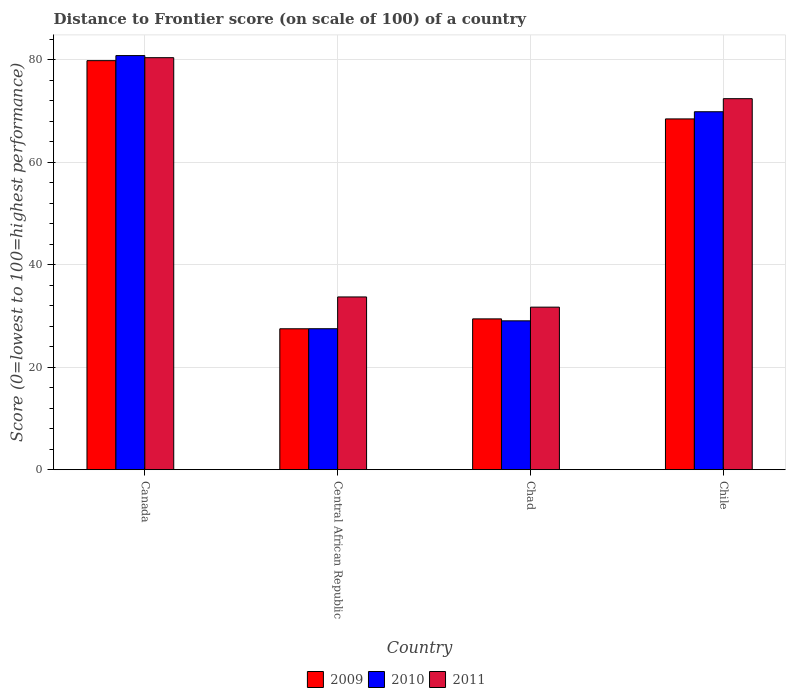How many different coloured bars are there?
Ensure brevity in your answer.  3. Are the number of bars on each tick of the X-axis equal?
Offer a very short reply. Yes. How many bars are there on the 4th tick from the left?
Provide a short and direct response. 3. How many bars are there on the 4th tick from the right?
Make the answer very short. 3. What is the label of the 4th group of bars from the left?
Keep it short and to the point. Chile. In how many cases, is the number of bars for a given country not equal to the number of legend labels?
Your answer should be compact. 0. What is the distance to frontier score of in 2009 in Chad?
Keep it short and to the point. 29.43. Across all countries, what is the maximum distance to frontier score of in 2009?
Your response must be concise. 79.82. Across all countries, what is the minimum distance to frontier score of in 2010?
Make the answer very short. 27.51. In which country was the distance to frontier score of in 2010 minimum?
Your response must be concise. Central African Republic. What is the total distance to frontier score of in 2011 in the graph?
Give a very brief answer. 218.23. What is the difference between the distance to frontier score of in 2010 in Central African Republic and that in Chile?
Provide a short and direct response. -42.34. What is the difference between the distance to frontier score of in 2009 in Canada and the distance to frontier score of in 2011 in Chad?
Provide a succinct answer. 48.1. What is the average distance to frontier score of in 2009 per country?
Your answer should be compact. 51.3. What is the difference between the distance to frontier score of of/in 2009 and distance to frontier score of of/in 2010 in Canada?
Make the answer very short. -0.99. In how many countries, is the distance to frontier score of in 2009 greater than 32?
Ensure brevity in your answer.  2. What is the ratio of the distance to frontier score of in 2010 in Chad to that in Chile?
Ensure brevity in your answer.  0.42. Is the distance to frontier score of in 2009 in Central African Republic less than that in Chad?
Ensure brevity in your answer.  Yes. What is the difference between the highest and the second highest distance to frontier score of in 2010?
Provide a short and direct response. 51.76. What is the difference between the highest and the lowest distance to frontier score of in 2010?
Offer a terse response. 53.3. In how many countries, is the distance to frontier score of in 2009 greater than the average distance to frontier score of in 2009 taken over all countries?
Offer a very short reply. 2. What does the 1st bar from the right in Chile represents?
Keep it short and to the point. 2011. Is it the case that in every country, the sum of the distance to frontier score of in 2011 and distance to frontier score of in 2009 is greater than the distance to frontier score of in 2010?
Offer a terse response. Yes. How many countries are there in the graph?
Provide a short and direct response. 4. Are the values on the major ticks of Y-axis written in scientific E-notation?
Your answer should be compact. No. Does the graph contain any zero values?
Your response must be concise. No. Where does the legend appear in the graph?
Keep it short and to the point. Bottom center. How many legend labels are there?
Keep it short and to the point. 3. What is the title of the graph?
Keep it short and to the point. Distance to Frontier score (on scale of 100) of a country. Does "1971" appear as one of the legend labels in the graph?
Offer a very short reply. No. What is the label or title of the X-axis?
Provide a succinct answer. Country. What is the label or title of the Y-axis?
Give a very brief answer. Score (0=lowest to 100=highest performance). What is the Score (0=lowest to 100=highest performance) of 2009 in Canada?
Provide a succinct answer. 79.82. What is the Score (0=lowest to 100=highest performance) of 2010 in Canada?
Your answer should be very brief. 80.81. What is the Score (0=lowest to 100=highest performance) in 2011 in Canada?
Make the answer very short. 80.4. What is the Score (0=lowest to 100=highest performance) of 2010 in Central African Republic?
Your answer should be compact. 27.51. What is the Score (0=lowest to 100=highest performance) in 2011 in Central African Republic?
Provide a short and direct response. 33.71. What is the Score (0=lowest to 100=highest performance) in 2009 in Chad?
Ensure brevity in your answer.  29.43. What is the Score (0=lowest to 100=highest performance) of 2010 in Chad?
Provide a short and direct response. 29.05. What is the Score (0=lowest to 100=highest performance) of 2011 in Chad?
Ensure brevity in your answer.  31.72. What is the Score (0=lowest to 100=highest performance) of 2009 in Chile?
Your answer should be compact. 68.45. What is the Score (0=lowest to 100=highest performance) in 2010 in Chile?
Offer a very short reply. 69.85. What is the Score (0=lowest to 100=highest performance) of 2011 in Chile?
Offer a terse response. 72.4. Across all countries, what is the maximum Score (0=lowest to 100=highest performance) in 2009?
Provide a succinct answer. 79.82. Across all countries, what is the maximum Score (0=lowest to 100=highest performance) in 2010?
Provide a succinct answer. 80.81. Across all countries, what is the maximum Score (0=lowest to 100=highest performance) in 2011?
Offer a very short reply. 80.4. Across all countries, what is the minimum Score (0=lowest to 100=highest performance) in 2009?
Give a very brief answer. 27.5. Across all countries, what is the minimum Score (0=lowest to 100=highest performance) in 2010?
Offer a terse response. 27.51. Across all countries, what is the minimum Score (0=lowest to 100=highest performance) in 2011?
Ensure brevity in your answer.  31.72. What is the total Score (0=lowest to 100=highest performance) in 2009 in the graph?
Your answer should be very brief. 205.2. What is the total Score (0=lowest to 100=highest performance) in 2010 in the graph?
Provide a short and direct response. 207.22. What is the total Score (0=lowest to 100=highest performance) of 2011 in the graph?
Ensure brevity in your answer.  218.23. What is the difference between the Score (0=lowest to 100=highest performance) in 2009 in Canada and that in Central African Republic?
Provide a short and direct response. 52.32. What is the difference between the Score (0=lowest to 100=highest performance) of 2010 in Canada and that in Central African Republic?
Your response must be concise. 53.3. What is the difference between the Score (0=lowest to 100=highest performance) in 2011 in Canada and that in Central African Republic?
Your answer should be very brief. 46.69. What is the difference between the Score (0=lowest to 100=highest performance) of 2009 in Canada and that in Chad?
Offer a terse response. 50.39. What is the difference between the Score (0=lowest to 100=highest performance) in 2010 in Canada and that in Chad?
Your answer should be very brief. 51.76. What is the difference between the Score (0=lowest to 100=highest performance) of 2011 in Canada and that in Chad?
Ensure brevity in your answer.  48.68. What is the difference between the Score (0=lowest to 100=highest performance) in 2009 in Canada and that in Chile?
Keep it short and to the point. 11.37. What is the difference between the Score (0=lowest to 100=highest performance) in 2010 in Canada and that in Chile?
Your answer should be compact. 10.96. What is the difference between the Score (0=lowest to 100=highest performance) of 2009 in Central African Republic and that in Chad?
Provide a succinct answer. -1.93. What is the difference between the Score (0=lowest to 100=highest performance) of 2010 in Central African Republic and that in Chad?
Your answer should be very brief. -1.54. What is the difference between the Score (0=lowest to 100=highest performance) of 2011 in Central African Republic and that in Chad?
Your response must be concise. 1.99. What is the difference between the Score (0=lowest to 100=highest performance) in 2009 in Central African Republic and that in Chile?
Your answer should be very brief. -40.95. What is the difference between the Score (0=lowest to 100=highest performance) of 2010 in Central African Republic and that in Chile?
Offer a very short reply. -42.34. What is the difference between the Score (0=lowest to 100=highest performance) in 2011 in Central African Republic and that in Chile?
Provide a succinct answer. -38.69. What is the difference between the Score (0=lowest to 100=highest performance) in 2009 in Chad and that in Chile?
Your answer should be very brief. -39.02. What is the difference between the Score (0=lowest to 100=highest performance) of 2010 in Chad and that in Chile?
Your answer should be compact. -40.8. What is the difference between the Score (0=lowest to 100=highest performance) in 2011 in Chad and that in Chile?
Ensure brevity in your answer.  -40.68. What is the difference between the Score (0=lowest to 100=highest performance) in 2009 in Canada and the Score (0=lowest to 100=highest performance) in 2010 in Central African Republic?
Offer a very short reply. 52.31. What is the difference between the Score (0=lowest to 100=highest performance) of 2009 in Canada and the Score (0=lowest to 100=highest performance) of 2011 in Central African Republic?
Your answer should be very brief. 46.11. What is the difference between the Score (0=lowest to 100=highest performance) of 2010 in Canada and the Score (0=lowest to 100=highest performance) of 2011 in Central African Republic?
Offer a terse response. 47.1. What is the difference between the Score (0=lowest to 100=highest performance) of 2009 in Canada and the Score (0=lowest to 100=highest performance) of 2010 in Chad?
Provide a short and direct response. 50.77. What is the difference between the Score (0=lowest to 100=highest performance) of 2009 in Canada and the Score (0=lowest to 100=highest performance) of 2011 in Chad?
Your answer should be very brief. 48.1. What is the difference between the Score (0=lowest to 100=highest performance) of 2010 in Canada and the Score (0=lowest to 100=highest performance) of 2011 in Chad?
Make the answer very short. 49.09. What is the difference between the Score (0=lowest to 100=highest performance) of 2009 in Canada and the Score (0=lowest to 100=highest performance) of 2010 in Chile?
Your answer should be very brief. 9.97. What is the difference between the Score (0=lowest to 100=highest performance) of 2009 in Canada and the Score (0=lowest to 100=highest performance) of 2011 in Chile?
Offer a terse response. 7.42. What is the difference between the Score (0=lowest to 100=highest performance) of 2010 in Canada and the Score (0=lowest to 100=highest performance) of 2011 in Chile?
Give a very brief answer. 8.41. What is the difference between the Score (0=lowest to 100=highest performance) of 2009 in Central African Republic and the Score (0=lowest to 100=highest performance) of 2010 in Chad?
Offer a terse response. -1.55. What is the difference between the Score (0=lowest to 100=highest performance) of 2009 in Central African Republic and the Score (0=lowest to 100=highest performance) of 2011 in Chad?
Your response must be concise. -4.22. What is the difference between the Score (0=lowest to 100=highest performance) of 2010 in Central African Republic and the Score (0=lowest to 100=highest performance) of 2011 in Chad?
Keep it short and to the point. -4.21. What is the difference between the Score (0=lowest to 100=highest performance) of 2009 in Central African Republic and the Score (0=lowest to 100=highest performance) of 2010 in Chile?
Offer a terse response. -42.35. What is the difference between the Score (0=lowest to 100=highest performance) in 2009 in Central African Republic and the Score (0=lowest to 100=highest performance) in 2011 in Chile?
Your answer should be very brief. -44.9. What is the difference between the Score (0=lowest to 100=highest performance) of 2010 in Central African Republic and the Score (0=lowest to 100=highest performance) of 2011 in Chile?
Your response must be concise. -44.89. What is the difference between the Score (0=lowest to 100=highest performance) in 2009 in Chad and the Score (0=lowest to 100=highest performance) in 2010 in Chile?
Provide a short and direct response. -40.42. What is the difference between the Score (0=lowest to 100=highest performance) in 2009 in Chad and the Score (0=lowest to 100=highest performance) in 2011 in Chile?
Your answer should be very brief. -42.97. What is the difference between the Score (0=lowest to 100=highest performance) of 2010 in Chad and the Score (0=lowest to 100=highest performance) of 2011 in Chile?
Your response must be concise. -43.35. What is the average Score (0=lowest to 100=highest performance) of 2009 per country?
Make the answer very short. 51.3. What is the average Score (0=lowest to 100=highest performance) in 2010 per country?
Offer a very short reply. 51.8. What is the average Score (0=lowest to 100=highest performance) in 2011 per country?
Your response must be concise. 54.56. What is the difference between the Score (0=lowest to 100=highest performance) in 2009 and Score (0=lowest to 100=highest performance) in 2010 in Canada?
Give a very brief answer. -0.99. What is the difference between the Score (0=lowest to 100=highest performance) in 2009 and Score (0=lowest to 100=highest performance) in 2011 in Canada?
Your answer should be very brief. -0.58. What is the difference between the Score (0=lowest to 100=highest performance) in 2010 and Score (0=lowest to 100=highest performance) in 2011 in Canada?
Give a very brief answer. 0.41. What is the difference between the Score (0=lowest to 100=highest performance) of 2009 and Score (0=lowest to 100=highest performance) of 2010 in Central African Republic?
Make the answer very short. -0.01. What is the difference between the Score (0=lowest to 100=highest performance) of 2009 and Score (0=lowest to 100=highest performance) of 2011 in Central African Republic?
Your answer should be compact. -6.21. What is the difference between the Score (0=lowest to 100=highest performance) in 2009 and Score (0=lowest to 100=highest performance) in 2010 in Chad?
Make the answer very short. 0.38. What is the difference between the Score (0=lowest to 100=highest performance) in 2009 and Score (0=lowest to 100=highest performance) in 2011 in Chad?
Offer a very short reply. -2.29. What is the difference between the Score (0=lowest to 100=highest performance) in 2010 and Score (0=lowest to 100=highest performance) in 2011 in Chad?
Keep it short and to the point. -2.67. What is the difference between the Score (0=lowest to 100=highest performance) in 2009 and Score (0=lowest to 100=highest performance) in 2010 in Chile?
Provide a succinct answer. -1.4. What is the difference between the Score (0=lowest to 100=highest performance) in 2009 and Score (0=lowest to 100=highest performance) in 2011 in Chile?
Give a very brief answer. -3.95. What is the difference between the Score (0=lowest to 100=highest performance) of 2010 and Score (0=lowest to 100=highest performance) of 2011 in Chile?
Give a very brief answer. -2.55. What is the ratio of the Score (0=lowest to 100=highest performance) in 2009 in Canada to that in Central African Republic?
Give a very brief answer. 2.9. What is the ratio of the Score (0=lowest to 100=highest performance) of 2010 in Canada to that in Central African Republic?
Your answer should be very brief. 2.94. What is the ratio of the Score (0=lowest to 100=highest performance) in 2011 in Canada to that in Central African Republic?
Give a very brief answer. 2.38. What is the ratio of the Score (0=lowest to 100=highest performance) of 2009 in Canada to that in Chad?
Provide a short and direct response. 2.71. What is the ratio of the Score (0=lowest to 100=highest performance) of 2010 in Canada to that in Chad?
Offer a terse response. 2.78. What is the ratio of the Score (0=lowest to 100=highest performance) of 2011 in Canada to that in Chad?
Make the answer very short. 2.53. What is the ratio of the Score (0=lowest to 100=highest performance) in 2009 in Canada to that in Chile?
Offer a very short reply. 1.17. What is the ratio of the Score (0=lowest to 100=highest performance) in 2010 in Canada to that in Chile?
Provide a succinct answer. 1.16. What is the ratio of the Score (0=lowest to 100=highest performance) of 2011 in Canada to that in Chile?
Ensure brevity in your answer.  1.11. What is the ratio of the Score (0=lowest to 100=highest performance) in 2009 in Central African Republic to that in Chad?
Your answer should be very brief. 0.93. What is the ratio of the Score (0=lowest to 100=highest performance) of 2010 in Central African Republic to that in Chad?
Make the answer very short. 0.95. What is the ratio of the Score (0=lowest to 100=highest performance) of 2011 in Central African Republic to that in Chad?
Your answer should be very brief. 1.06. What is the ratio of the Score (0=lowest to 100=highest performance) in 2009 in Central African Republic to that in Chile?
Your answer should be very brief. 0.4. What is the ratio of the Score (0=lowest to 100=highest performance) of 2010 in Central African Republic to that in Chile?
Ensure brevity in your answer.  0.39. What is the ratio of the Score (0=lowest to 100=highest performance) in 2011 in Central African Republic to that in Chile?
Keep it short and to the point. 0.47. What is the ratio of the Score (0=lowest to 100=highest performance) of 2009 in Chad to that in Chile?
Ensure brevity in your answer.  0.43. What is the ratio of the Score (0=lowest to 100=highest performance) of 2010 in Chad to that in Chile?
Your answer should be very brief. 0.42. What is the ratio of the Score (0=lowest to 100=highest performance) in 2011 in Chad to that in Chile?
Offer a terse response. 0.44. What is the difference between the highest and the second highest Score (0=lowest to 100=highest performance) of 2009?
Keep it short and to the point. 11.37. What is the difference between the highest and the second highest Score (0=lowest to 100=highest performance) in 2010?
Offer a terse response. 10.96. What is the difference between the highest and the lowest Score (0=lowest to 100=highest performance) in 2009?
Your answer should be very brief. 52.32. What is the difference between the highest and the lowest Score (0=lowest to 100=highest performance) of 2010?
Offer a very short reply. 53.3. What is the difference between the highest and the lowest Score (0=lowest to 100=highest performance) of 2011?
Your response must be concise. 48.68. 